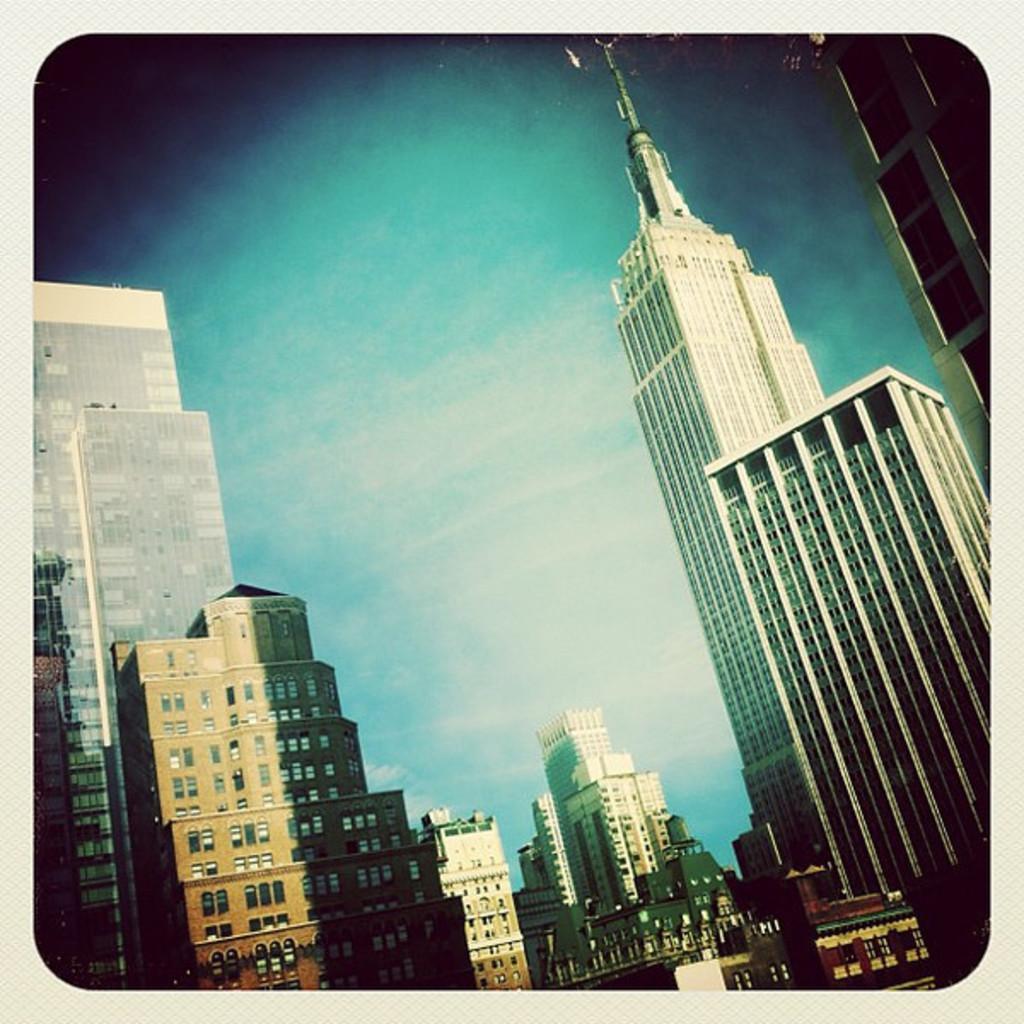How would you summarize this image in a sentence or two? In this image I can see few buildings and windows. The sky is blue and white color. 